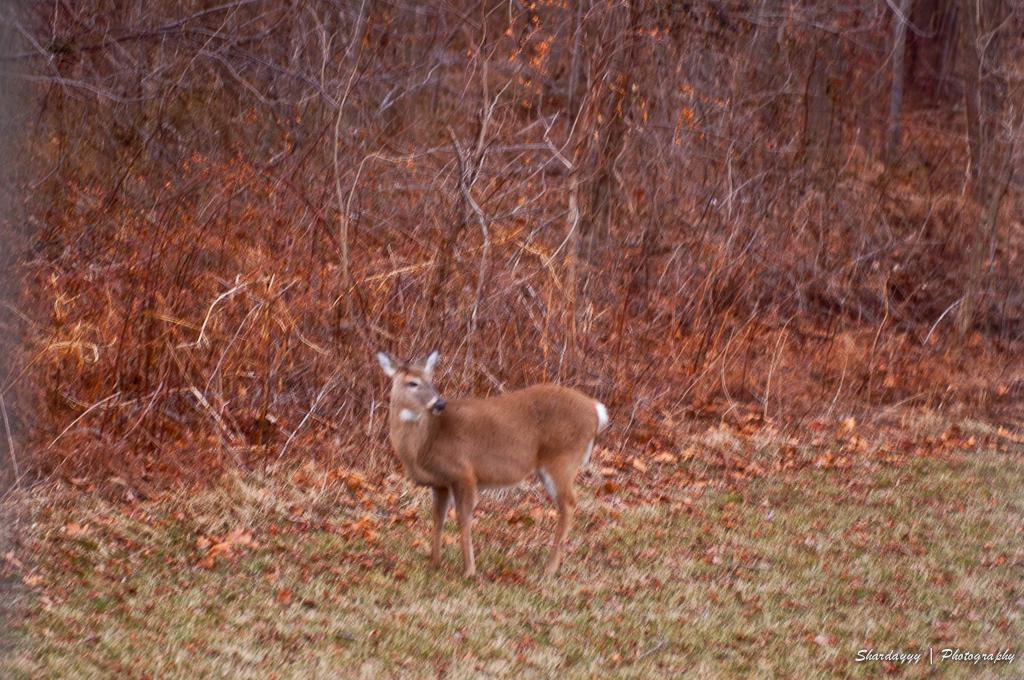In one or two sentences, can you explain what this image depicts? In this image there is a deer standing on the ground. There are dried leaves and grass and on the ground. Behind it there are dried trees. In the bottom right there is text on the image. 